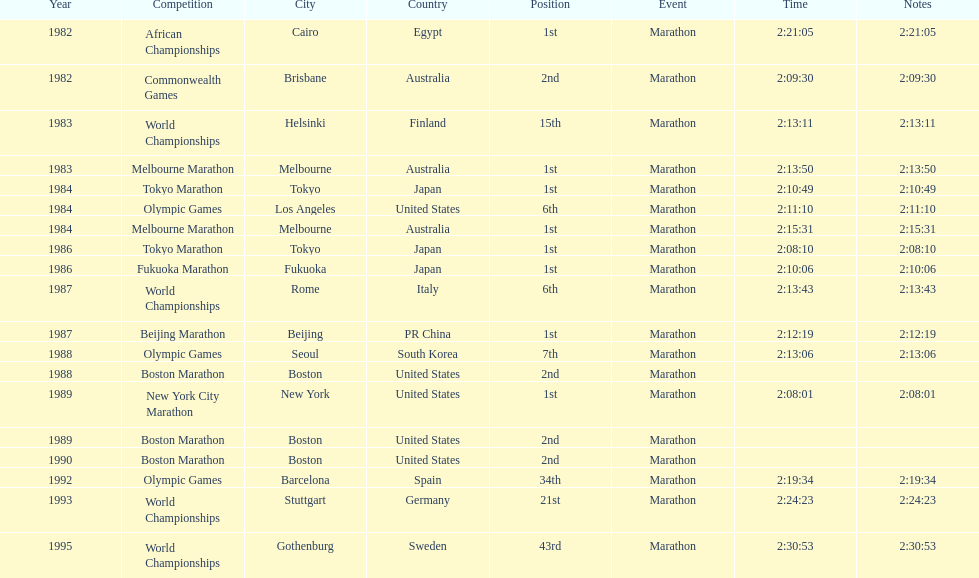What are the total number of times the position of 1st place was earned? 8. 